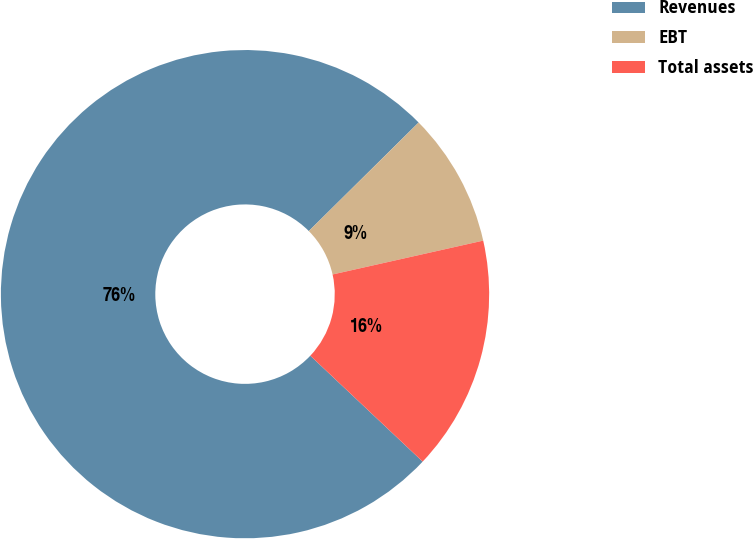<chart> <loc_0><loc_0><loc_500><loc_500><pie_chart><fcel>Revenues<fcel>EBT<fcel>Total assets<nl><fcel>75.56%<fcel>8.89%<fcel>15.55%<nl></chart> 